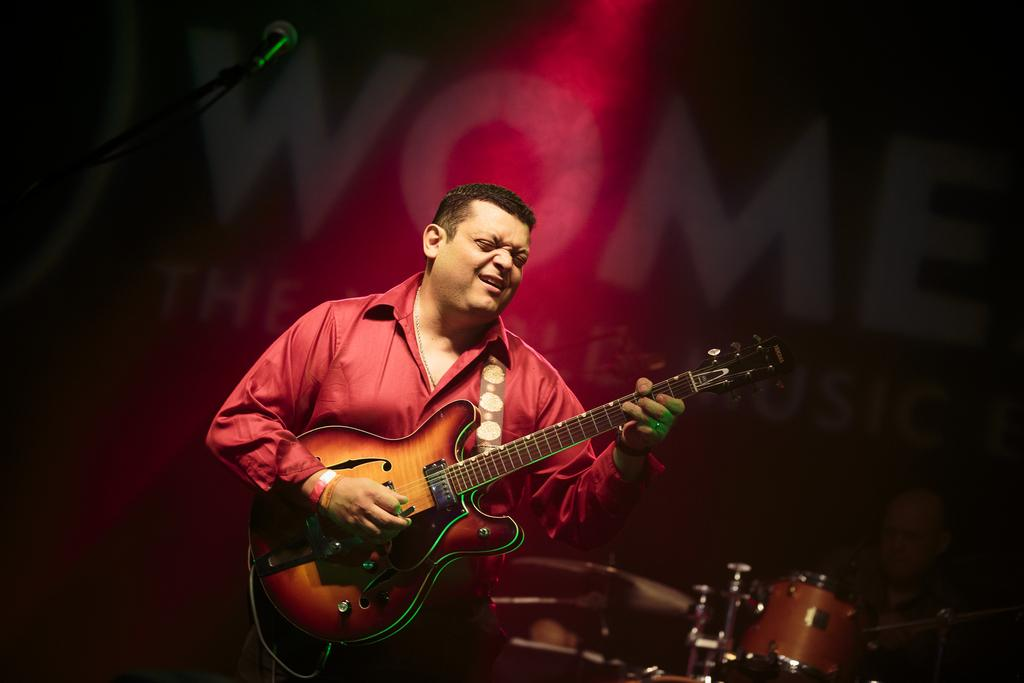What is the person in the image doing? The person is holding a guitar. What might the person be about to do with the guitar? The person might be about to play the guitar, as their mouth is open. What color is the shirt the person is wearing? The person is wearing a red color shirt. What can be seen on the left side of the image? There is a microphone on the left side of the image. What can be seen on the right side of the image? There is a drum on the right side of the image. How many cows are visible in the image? There are no cows present in the image. What word is the person singing in the image? There is no indication of the person singing or any specific word in the image. 